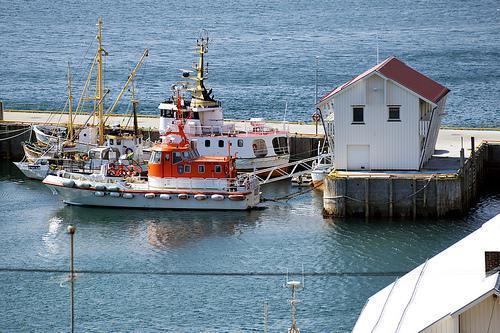How many boats are there?
Give a very brief answer. 2. 